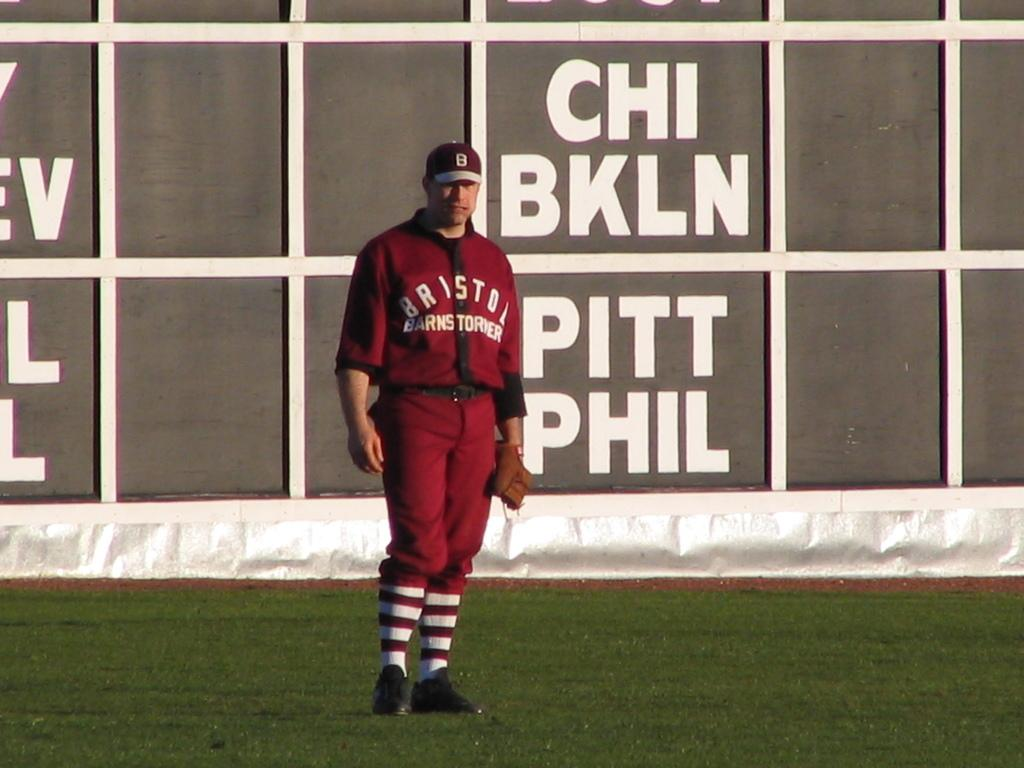<image>
Give a short and clear explanation of the subsequent image. A man in a red baseball uniform stands in front of a board with abbreviations for team names, including CHI, BKLN, PITT and PHIL. 